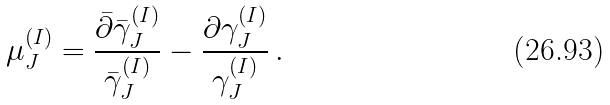Convert formula to latex. <formula><loc_0><loc_0><loc_500><loc_500>\mu _ { J } ^ { ( I ) } = \frac { \bar { \partial } \bar { \gamma } _ { J } ^ { ( I ) } } { \bar { \gamma } _ { J } ^ { ( I ) } } - \frac { \partial \gamma _ { J } ^ { ( I ) } } { \gamma _ { J } ^ { ( I ) } } \, .</formula> 